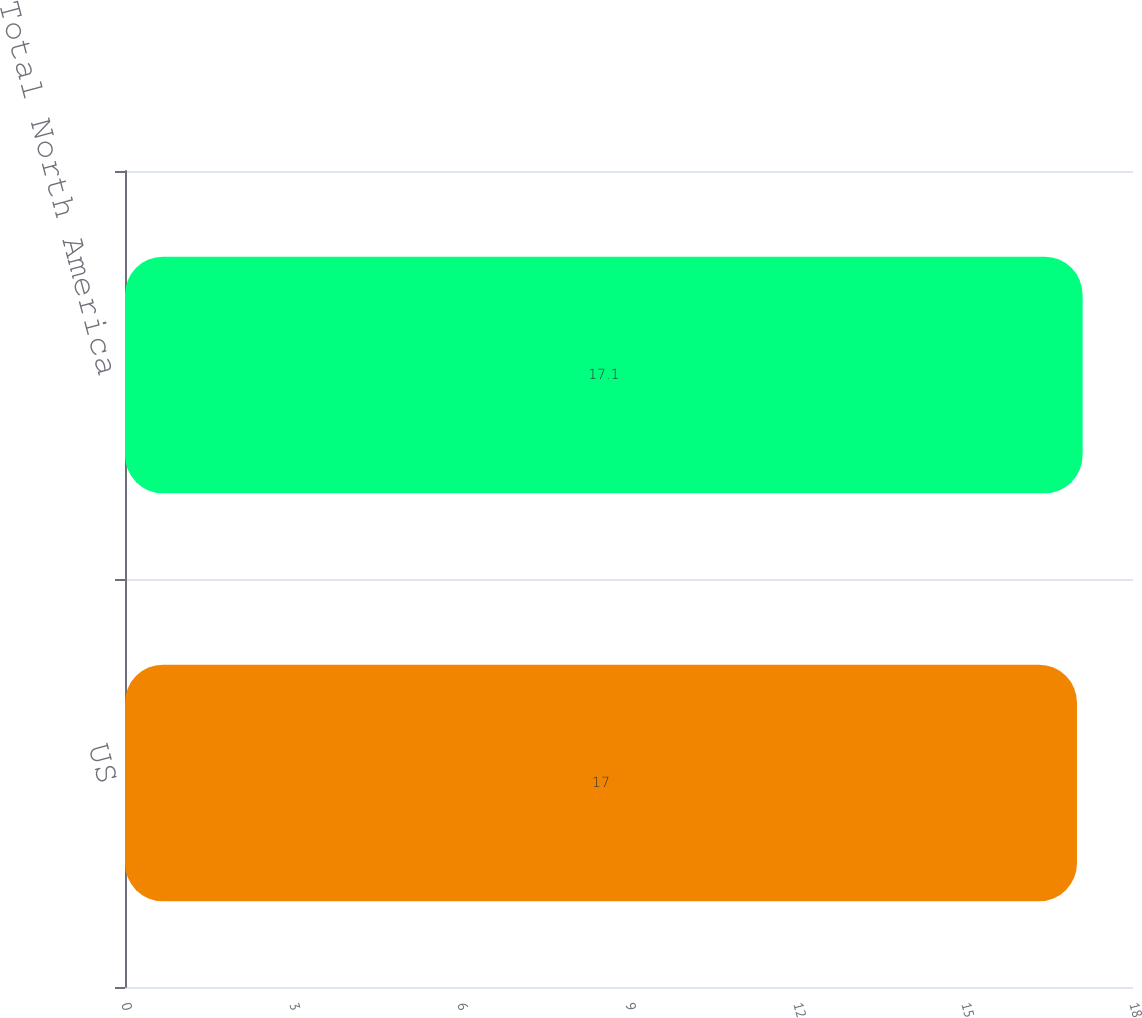Convert chart. <chart><loc_0><loc_0><loc_500><loc_500><bar_chart><fcel>US<fcel>Total North America<nl><fcel>17<fcel>17.1<nl></chart> 